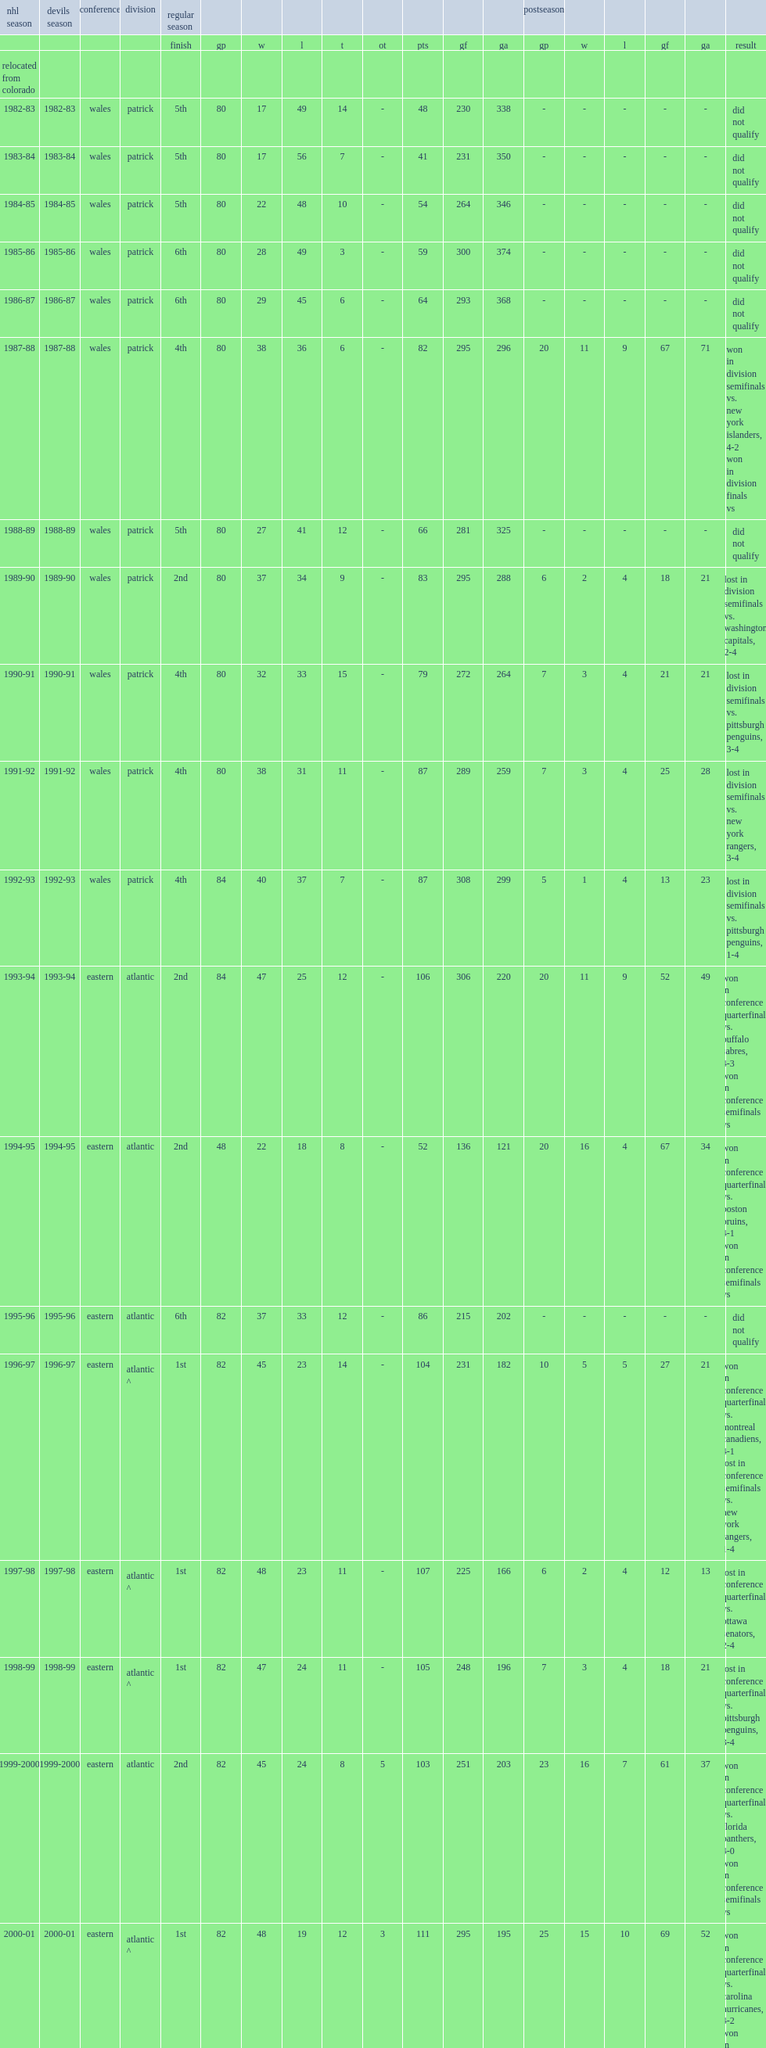Parse the table in full. {'header': ['nhl season', 'devils season', 'conference', 'division', 'regular season', '', '', '', '', '', '', '', '', 'postseason', '', '', '', '', ''], 'rows': [['', '', '', '', 'finish', 'gp', 'w', 'l', 't', 'ot', 'pts', 'gf', 'ga', 'gp', 'w', 'l', 'gf', 'ga', 'result'], ['relocated from colorado', '', '', '', '', '', '', '', '', '', '', '', '', '', '', '', '', '', ''], ['1982-83', '1982-83', 'wales', 'patrick', '5th', '80', '17', '49', '14', '-', '48', '230', '338', '-', '-', '-', '-', '-', 'did not qualify'], ['1983-84', '1983-84', 'wales', 'patrick', '5th', '80', '17', '56', '7', '-', '41', '231', '350', '-', '-', '-', '-', '-', 'did not qualify'], ['1984-85', '1984-85', 'wales', 'patrick', '5th', '80', '22', '48', '10', '-', '54', '264', '346', '-', '-', '-', '-', '-', 'did not qualify'], ['1985-86', '1985-86', 'wales', 'patrick', '6th', '80', '28', '49', '3', '-', '59', '300', '374', '-', '-', '-', '-', '-', 'did not qualify'], ['1986-87', '1986-87', 'wales', 'patrick', '6th', '80', '29', '45', '6', '-', '64', '293', '368', '-', '-', '-', '-', '-', 'did not qualify'], ['1987-88', '1987-88', 'wales', 'patrick', '4th', '80', '38', '36', '6', '-', '82', '295', '296', '20', '11', '9', '67', '71', 'won in division semifinals vs. new york islanders, 4-2 won in division finals vs'], ['1988-89', '1988-89', 'wales', 'patrick', '5th', '80', '27', '41', '12', '-', '66', '281', '325', '-', '-', '-', '-', '-', 'did not qualify'], ['1989-90', '1989-90', 'wales', 'patrick', '2nd', '80', '37', '34', '9', '-', '83', '295', '288', '6', '2', '4', '18', '21', 'lost in division semifinals vs. washington capitals, 2-4'], ['1990-91', '1990-91', 'wales', 'patrick', '4th', '80', '32', '33', '15', '-', '79', '272', '264', '7', '3', '4', '21', '21', 'lost in division semifinals vs. pittsburgh penguins, 3-4'], ['1991-92', '1991-92', 'wales', 'patrick', '4th', '80', '38', '31', '11', '-', '87', '289', '259', '7', '3', '4', '25', '28', 'lost in division semifinals vs. new york rangers, 3-4'], ['1992-93', '1992-93', 'wales', 'patrick', '4th', '84', '40', '37', '7', '-', '87', '308', '299', '5', '1', '4', '13', '23', 'lost in division semifinals vs. pittsburgh penguins, 1-4'], ['1993-94', '1993-94', 'eastern', 'atlantic', '2nd', '84', '47', '25', '12', '-', '106', '306', '220', '20', '11', '9', '52', '49', 'won in conference quarterfinals vs. buffalo sabres, 4-3 won in conference semifinals vs'], ['1994-95', '1994-95', 'eastern', 'atlantic', '2nd', '48', '22', '18', '8', '-', '52', '136', '121', '20', '16', '4', '67', '34', 'won in conference quarterfinals vs. boston bruins, 4-1 won in conference semifinals vs'], ['1995-96', '1995-96', 'eastern', 'atlantic', '6th', '82', '37', '33', '12', '-', '86', '215', '202', '-', '-', '-', '-', '-', 'did not qualify'], ['1996-97', '1996-97', 'eastern', 'atlantic ^', '1st', '82', '45', '23', '14', '-', '104', '231', '182', '10', '5', '5', '27', '21', 'won in conference quarterfinals vs. montreal canadiens, 4-1 lost in conference semifinals vs. new york rangers, 1-4'], ['1997-98', '1997-98', 'eastern', 'atlantic ^', '1st', '82', '48', '23', '11', '-', '107', '225', '166', '6', '2', '4', '12', '13', 'lost in conference quarterfinals vs. ottawa senators, 2-4'], ['1998-99', '1998-99', 'eastern', 'atlantic ^', '1st', '82', '47', '24', '11', '-', '105', '248', '196', '7', '3', '4', '18', '21', 'lost in conference quarterfinals vs. pittsburgh penguins, 3-4'], ['1999-2000', '1999-2000', 'eastern', 'atlantic', '2nd', '82', '45', '24', '8', '5', '103', '251', '203', '23', '16', '7', '61', '37', 'won in conference quarterfinals vs. florida panthers, 4-0 won in conference semifinals vs'], ['2000-01', '2000-01', 'eastern', 'atlantic ^', '1st', '82', '48', '19', '12', '3', '111', '295', '195', '25', '15', '10', '69', '52', 'won in conference quarterfinals vs. carolina hurricanes, 4-2 won in conference semifinals vs'], ['2001-02', '2001-02', 'eastern', 'atlantic', '3rd', '82', '41', '28', '9', '4', '95', '205', '187', '6', '2', '4', '11', '9', 'lost in conference quarterfinals vs. carolina hurricanes, 2-4'], ['2002-03', '2002-03', 'eastern', 'atlantic ^', '1st', '82', '46', '20', '10', '6', '108', '216', '166', '24', '16', '8', '63', '38', 'won in conference quarterfinals vs. boston bruins, 4-1 won in conference semifinals vs'], ['2003-04', '2003-04', 'eastern', 'atlantic', '2nd', '82', '43', '25', '12', '2', '100', '213', '164', '5', '1', '4', '9', '14', 'lost in conference quarterfinals vs. philadelphia flyers, 1-4'], ['2004-05', '2004-05', 'eastern', 'atlantic', 'season not played due to lockout', '', '', '', '', '', '', '', '', '', '', '', '', '', ''], ['2005-06', '2005-06', 'eastern', 'atlantic ^', '1st', '82', '46', '27', '-', '9', '101', '242', '229', '9', '5', '4', '27', '21', 'won in conference quarterfinals vs. new york rangers, 4-0 lost in conference semifinals vs. carolina hurricanes, 1-4'], ['2006-07', '2006-07', 'eastern', 'atlantic ^', '1st', '82', '49', '24', '-', '9', '107', '216', '201', '11', '5', '6', '30', '29', 'won in conference quarterfinals vs. tampa bay lightning, 4-2 lost in conference semifinals vs. ottawa senators, 1-4'], ['2007-08', '2007-08', 'eastern', 'atlantic', '2nd', '82', '46', '29', '-', '7', '99', '206', '197', '5', '1', '4', '12', '19', 'lost in conference quarterfinals vs. new york rangers, 1-4'], ['2008-09', '2008-09', 'eastern', 'atlantic ^', '1st', '82', '51', '27', '-', '4', '106', '244', '209', '7', '3', '4', '15', '17', 'lost in conference quarterfinals vs. carolina hurricanes, 3-4'], ['2009-10', '2009-10', 'eastern', 'atlantic ^', '1st', '82', '48', '27', '-', '7', '103', '216', '186', '5', '1', '4', '9', '15', 'lost in conference quarterfinals vs. philadelphia flyers, 1-4'], ['2010-11', '2010-11', 'eastern', 'atlantic', '4th', '82', '38', '39', '-', '5', '81', '174', '209', '-', '-', '-', '-', '-', 'did not qualify'], ['2011-12', '2011-12', 'eastern', 'atlantic', '4th', '82', '48', '28', '-', '6', '102', '228', '202', '24', '14', '10', '51', '42', 'won in conference quarterfinals vs. florida panthers, 4-3 won in conference semifinals vs'], ['2012-13', '2012-13', 'eastern', 'atlantic', '5th', '48', '19', '19', '-', '10', '48', '112', '129', '-', '-', '-', '-', '-', 'did not qualify'], ['2013-14', '2013-14', 'eastern', 'metropolitan', '6th', '82', '35', '29', '-', '18', '88', '197', '208', '-', '-', '-', '-', '-', 'did not qualify'], ['2014-15', '2014-15', 'eastern', 'metropolitan', '7th', '82', '32', '36', '-', '14', '78', '181', '216', '-', '-', '-', '-', '-', 'did not qualify'], ['2015-16', '2015-16', 'eastern', 'metropolitan', '7th', '82', '38', '36', '-', '8', '84', '184', '208', '-', '-', '-', '-', '-', 'did not qualify'], ['2016-17', '2016-17', 'eastern', 'metropolitan', '8th', '82', '28', '40', '-', '14', '70', '183', '244', '-', '-', '-', '-', '-', 'did not qualify'], ['2017-18', '2017-18', 'eastern', 'metropolitan', '5th', '82', '44', '29', '-', '9', '97', '248', '244', '5', '1', '4', '12', '18', 'lost in first round vs. tampa bay lightning 1-4'], ['2018-19', '2018-19', 'eastern', 'metropolitan', '8th', '82', '31', '41', '-', '10', '72', '222', '275', '-', '-', '-', '-', '-', 'did not qualify'], ['totals', '', '', '', '', '2,868', '1,347', '1,152', '219', '150', '3,063', '8,452', '8,466', '257', '137', '120', '689', '613', 'none']]} Which season was the team's 20th season? 2001-02. 